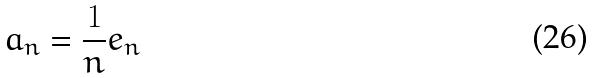Convert formula to latex. <formula><loc_0><loc_0><loc_500><loc_500>a _ { n } = \frac { 1 } { n } e _ { n }</formula> 